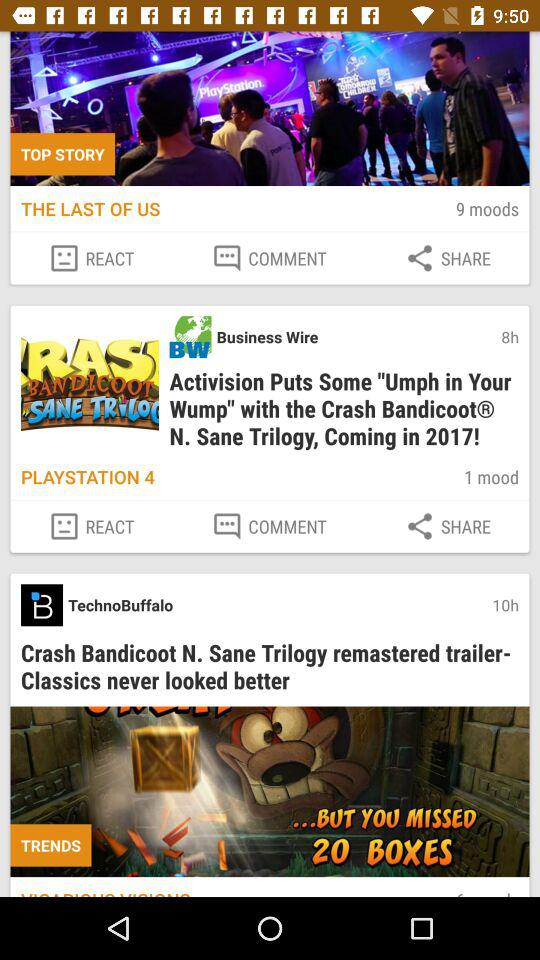How many more moods are there on the top story than the second story?
Answer the question using a single word or phrase. 8 